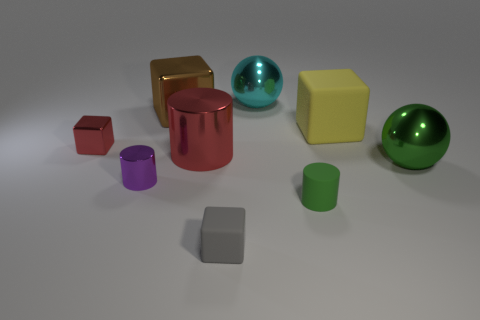Subtract 2 cubes. How many cubes are left? 2 Subtract all tiny cylinders. How many cylinders are left? 1 Subtract all purple blocks. Subtract all red cylinders. How many blocks are left? 4 Subtract all cylinders. How many objects are left? 6 Subtract all green balls. Subtract all tiny red shiny blocks. How many objects are left? 7 Add 3 tiny green rubber cylinders. How many tiny green rubber cylinders are left? 4 Add 3 tiny gray rubber things. How many tiny gray rubber things exist? 4 Subtract 0 brown cylinders. How many objects are left? 9 